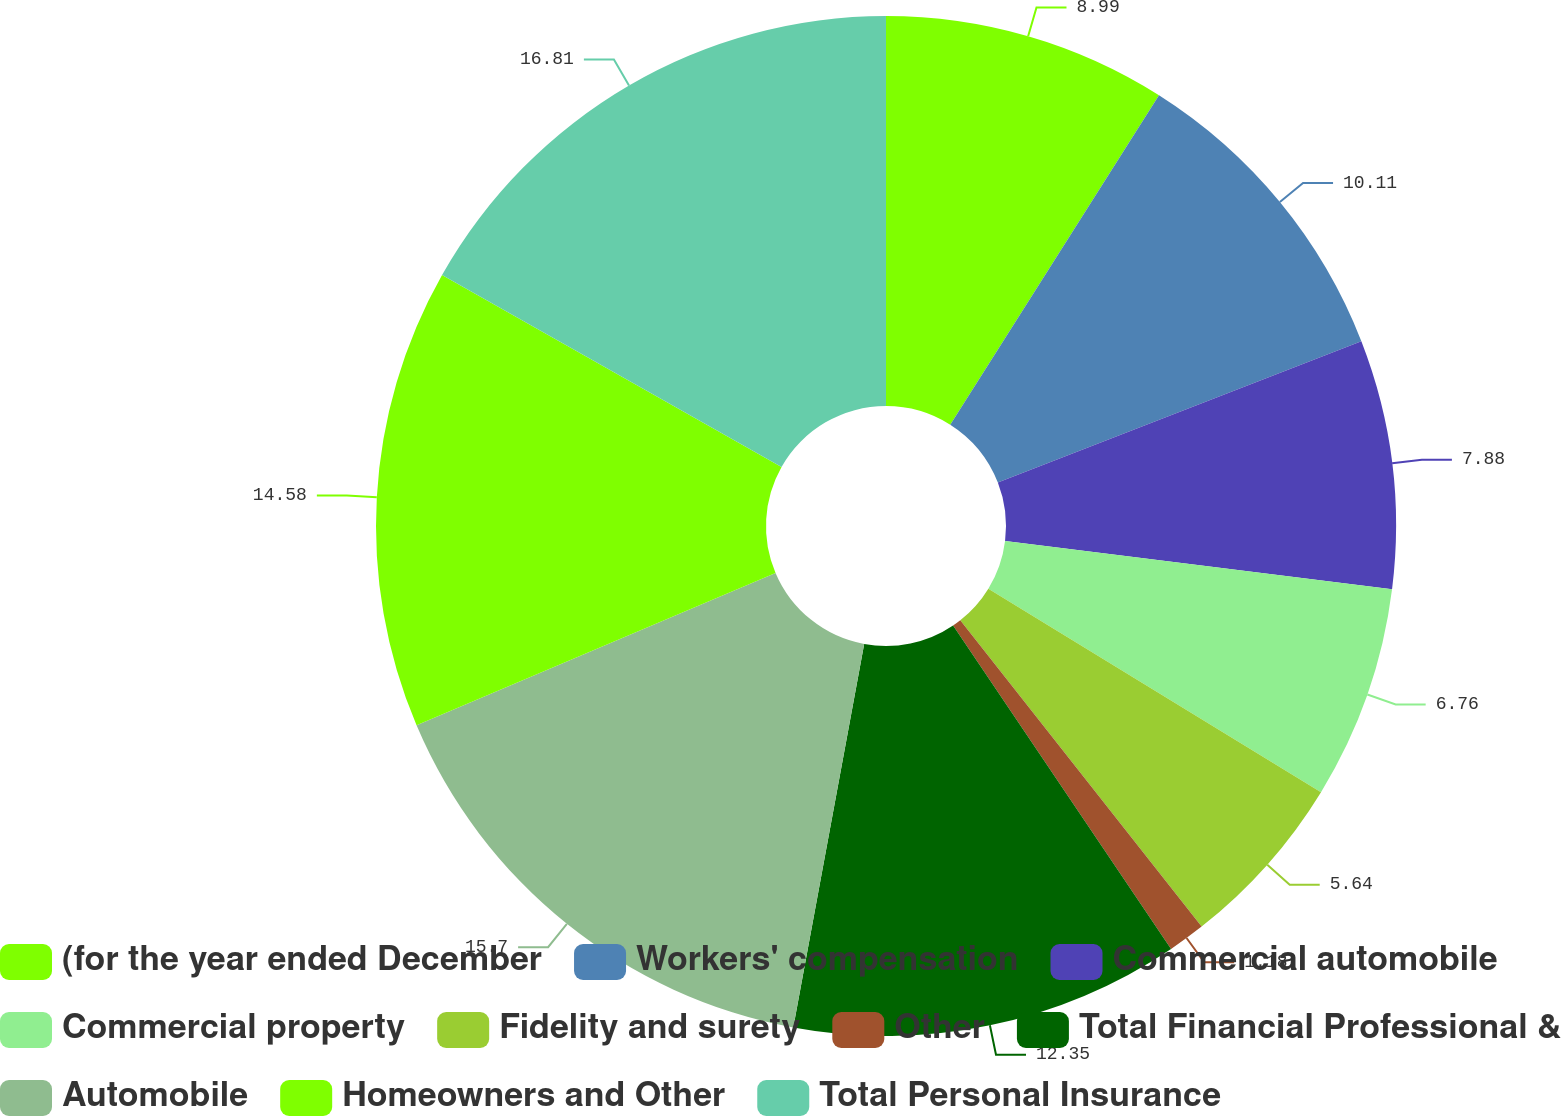Convert chart to OTSL. <chart><loc_0><loc_0><loc_500><loc_500><pie_chart><fcel>(for the year ended December<fcel>Workers' compensation<fcel>Commercial automobile<fcel>Commercial property<fcel>Fidelity and surety<fcel>Other<fcel>Total Financial Professional &<fcel>Automobile<fcel>Homeowners and Other<fcel>Total Personal Insurance<nl><fcel>8.99%<fcel>10.11%<fcel>7.88%<fcel>6.76%<fcel>5.64%<fcel>1.18%<fcel>12.35%<fcel>15.7%<fcel>14.58%<fcel>16.81%<nl></chart> 